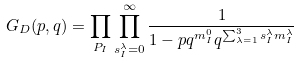<formula> <loc_0><loc_0><loc_500><loc_500>G _ { D } ( p , q ) = \prod _ { P _ { I } } \prod _ { s _ { I } ^ { \lambda } = 0 } ^ { \infty } \frac { 1 } { 1 - p q ^ { m _ { I } ^ { 0 } } q ^ { \sum _ { \lambda = 1 } ^ { 3 } s _ { I } ^ { \lambda } m _ { I } ^ { \lambda } } }</formula> 